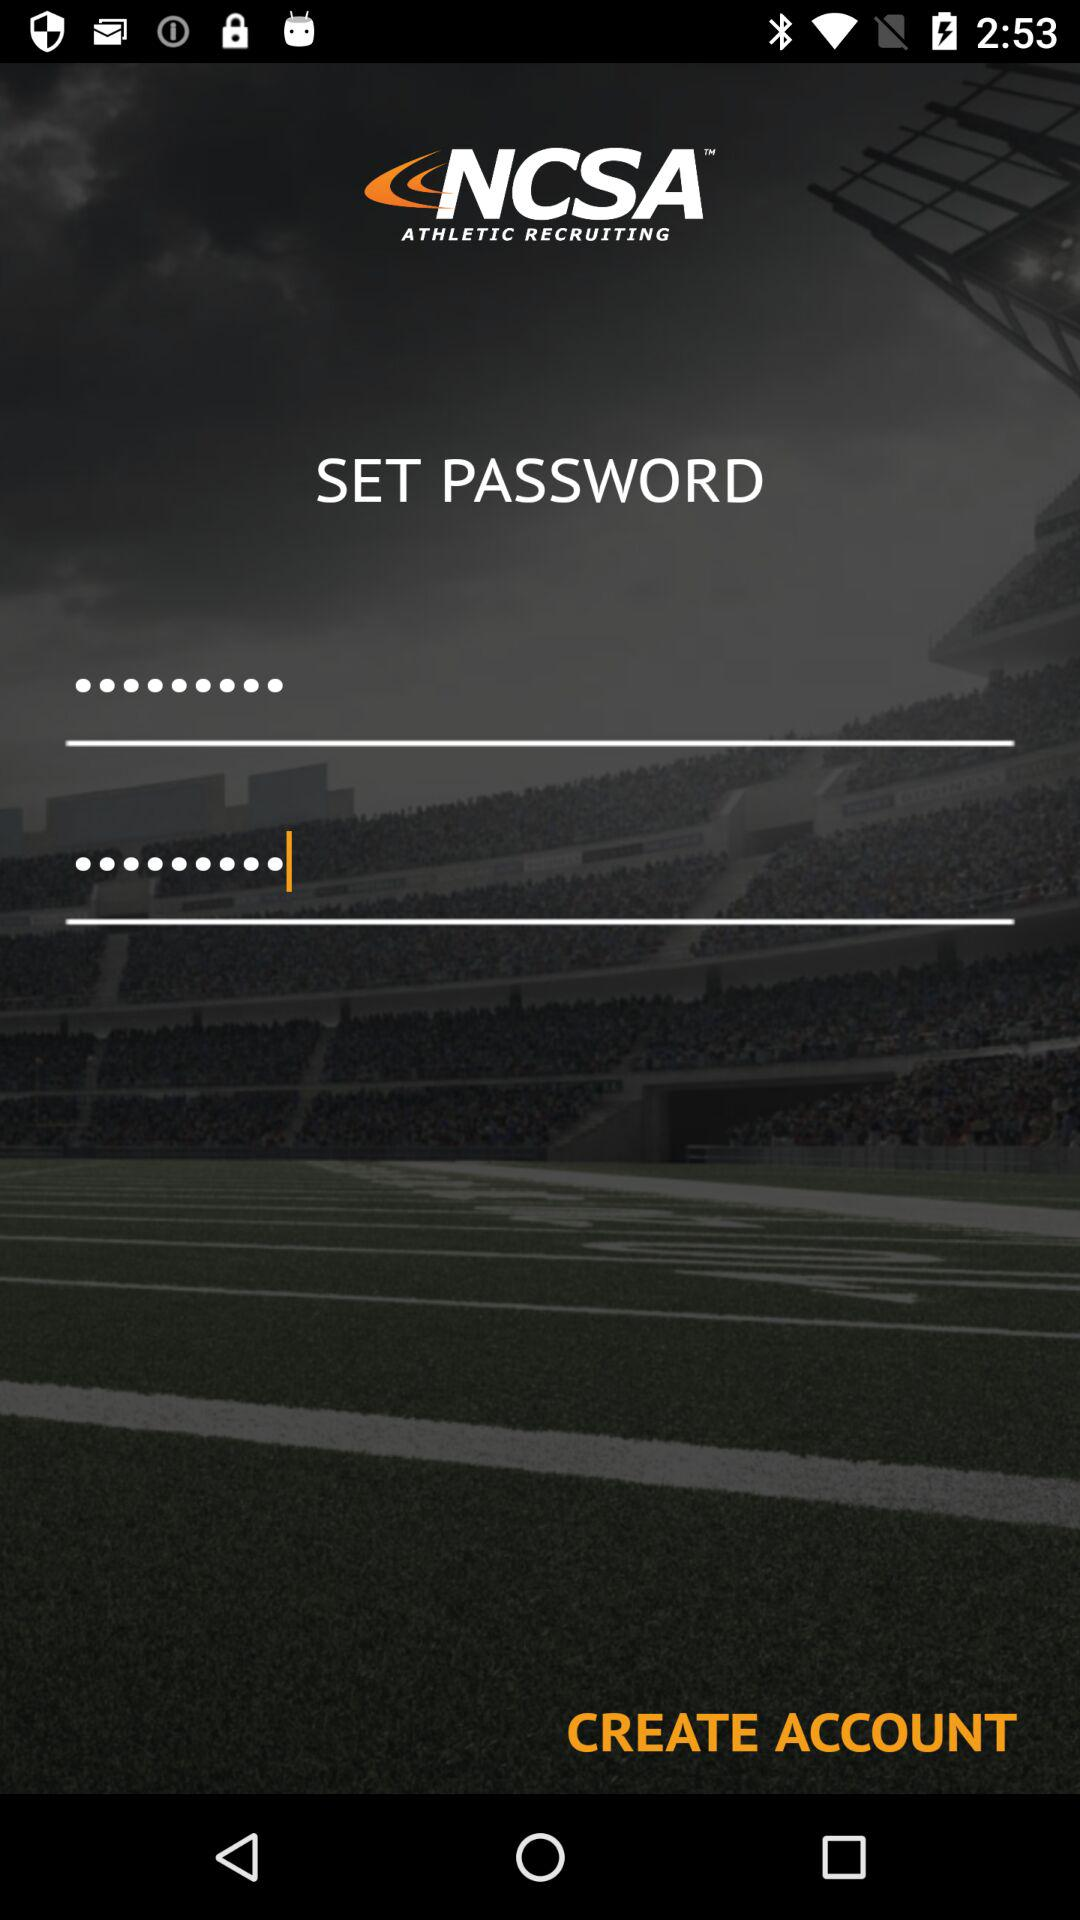How many characters are required for the password?
When the provided information is insufficient, respond with <no answer>. <no answer> 